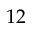<formula> <loc_0><loc_0><loc_500><loc_500>1 2</formula> 